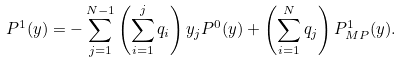Convert formula to latex. <formula><loc_0><loc_0><loc_500><loc_500>P ^ { 1 } ( { y } ) = - \sum ^ { N - 1 } _ { j = 1 } \left ( \sum ^ { j } _ { i = 1 } q _ { i } \right ) y _ { j } P ^ { 0 } ( { y } ) + \left ( \sum ^ { N } _ { i = 1 } q _ { j } \right ) P ^ { 1 } _ { M P } ( { y } ) .</formula> 